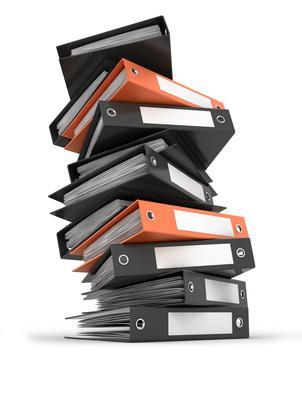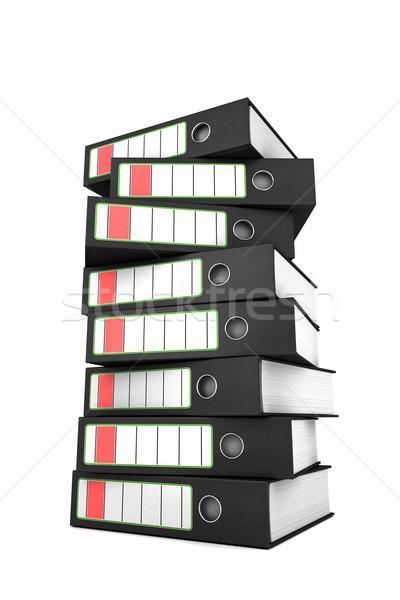The first image is the image on the left, the second image is the image on the right. For the images displayed, is the sentence "An image shows only arms in black sleeves sticking out from behind a stack of binders, all with open ends showing." factually correct? Answer yes or no. No. The first image is the image on the left, the second image is the image on the right. Evaluate the accuracy of this statement regarding the images: "A man's face is visible near a stack of books.". Is it true? Answer yes or no. No. 